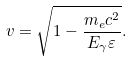Convert formula to latex. <formula><loc_0><loc_0><loc_500><loc_500>v = \sqrt { 1 - \frac { m _ { e } c ^ { 2 } } { E _ { \gamma } \varepsilon } } .</formula> 